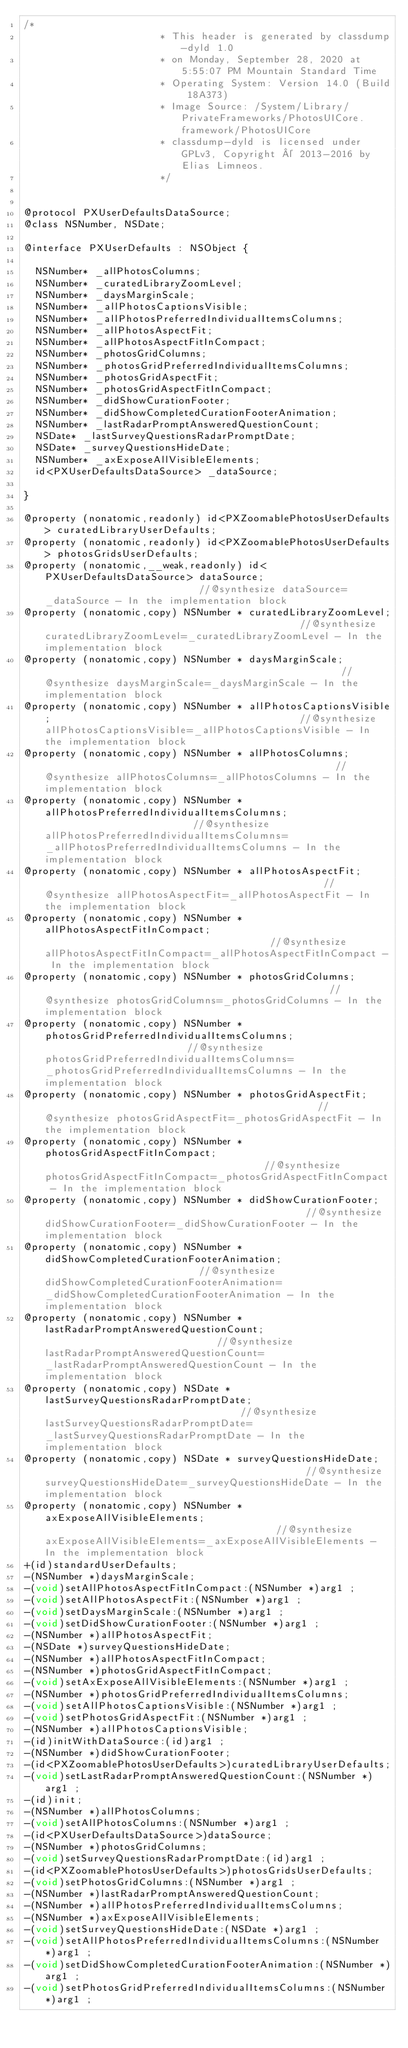<code> <loc_0><loc_0><loc_500><loc_500><_C_>/*
                       * This header is generated by classdump-dyld 1.0
                       * on Monday, September 28, 2020 at 5:55:07 PM Mountain Standard Time
                       * Operating System: Version 14.0 (Build 18A373)
                       * Image Source: /System/Library/PrivateFrameworks/PhotosUICore.framework/PhotosUICore
                       * classdump-dyld is licensed under GPLv3, Copyright © 2013-2016 by Elias Limneos.
                       */


@protocol PXUserDefaultsDataSource;
@class NSNumber, NSDate;

@interface PXUserDefaults : NSObject {

	NSNumber* _allPhotosColumns;
	NSNumber* _curatedLibraryZoomLevel;
	NSNumber* _daysMarginScale;
	NSNumber* _allPhotosCaptionsVisible;
	NSNumber* _allPhotosPreferredIndividualItemsColumns;
	NSNumber* _allPhotosAspectFit;
	NSNumber* _allPhotosAspectFitInCompact;
	NSNumber* _photosGridColumns;
	NSNumber* _photosGridPreferredIndividualItemsColumns;
	NSNumber* _photosGridAspectFit;
	NSNumber* _photosGridAspectFitInCompact;
	NSNumber* _didShowCurationFooter;
	NSNumber* _didShowCompletedCurationFooterAnimation;
	NSNumber* _lastRadarPromptAnsweredQuestionCount;
	NSDate* _lastSurveyQuestionsRadarPromptDate;
	NSDate* _surveyQuestionsHideDate;
	NSNumber* _axExposeAllVisibleElements;
	id<PXUserDefaultsDataSource> _dataSource;

}

@property (nonatomic,readonly) id<PXZoomablePhotosUserDefaults> curatedLibraryUserDefaults; 
@property (nonatomic,readonly) id<PXZoomablePhotosUserDefaults> photosGridsUserDefaults; 
@property (nonatomic,__weak,readonly) id<PXUserDefaultsDataSource> dataSource;                           //@synthesize dataSource=_dataSource - In the implementation block
@property (nonatomic,copy) NSNumber * curatedLibraryZoomLevel;                                           //@synthesize curatedLibraryZoomLevel=_curatedLibraryZoomLevel - In the implementation block
@property (nonatomic,copy) NSNumber * daysMarginScale;                                                   //@synthesize daysMarginScale=_daysMarginScale - In the implementation block
@property (nonatomic,copy) NSNumber * allPhotosCaptionsVisible;                                          //@synthesize allPhotosCaptionsVisible=_allPhotosCaptionsVisible - In the implementation block
@property (nonatomic,copy) NSNumber * allPhotosColumns;                                                  //@synthesize allPhotosColumns=_allPhotosColumns - In the implementation block
@property (nonatomic,copy) NSNumber * allPhotosPreferredIndividualItemsColumns;                          //@synthesize allPhotosPreferredIndividualItemsColumns=_allPhotosPreferredIndividualItemsColumns - In the implementation block
@property (nonatomic,copy) NSNumber * allPhotosAspectFit;                                                //@synthesize allPhotosAspectFit=_allPhotosAspectFit - In the implementation block
@property (nonatomic,copy) NSNumber * allPhotosAspectFitInCompact;                                       //@synthesize allPhotosAspectFitInCompact=_allPhotosAspectFitInCompact - In the implementation block
@property (nonatomic,copy) NSNumber * photosGridColumns;                                                 //@synthesize photosGridColumns=_photosGridColumns - In the implementation block
@property (nonatomic,copy) NSNumber * photosGridPreferredIndividualItemsColumns;                         //@synthesize photosGridPreferredIndividualItemsColumns=_photosGridPreferredIndividualItemsColumns - In the implementation block
@property (nonatomic,copy) NSNumber * photosGridAspectFit;                                               //@synthesize photosGridAspectFit=_photosGridAspectFit - In the implementation block
@property (nonatomic,copy) NSNumber * photosGridAspectFitInCompact;                                      //@synthesize photosGridAspectFitInCompact=_photosGridAspectFitInCompact - In the implementation block
@property (nonatomic,copy) NSNumber * didShowCurationFooter;                                             //@synthesize didShowCurationFooter=_didShowCurationFooter - In the implementation block
@property (nonatomic,copy) NSNumber * didShowCompletedCurationFooterAnimation;                           //@synthesize didShowCompletedCurationFooterAnimation=_didShowCompletedCurationFooterAnimation - In the implementation block
@property (nonatomic,copy) NSNumber * lastRadarPromptAnsweredQuestionCount;                              //@synthesize lastRadarPromptAnsweredQuestionCount=_lastRadarPromptAnsweredQuestionCount - In the implementation block
@property (nonatomic,copy) NSDate * lastSurveyQuestionsRadarPromptDate;                                  //@synthesize lastSurveyQuestionsRadarPromptDate=_lastSurveyQuestionsRadarPromptDate - In the implementation block
@property (nonatomic,copy) NSDate * surveyQuestionsHideDate;                                             //@synthesize surveyQuestionsHideDate=_surveyQuestionsHideDate - In the implementation block
@property (nonatomic,copy) NSNumber * axExposeAllVisibleElements;                                        //@synthesize axExposeAllVisibleElements=_axExposeAllVisibleElements - In the implementation block
+(id)standardUserDefaults;
-(NSNumber *)daysMarginScale;
-(void)setAllPhotosAspectFitInCompact:(NSNumber *)arg1 ;
-(void)setAllPhotosAspectFit:(NSNumber *)arg1 ;
-(void)setDaysMarginScale:(NSNumber *)arg1 ;
-(void)setDidShowCurationFooter:(NSNumber *)arg1 ;
-(NSNumber *)allPhotosAspectFit;
-(NSDate *)surveyQuestionsHideDate;
-(NSNumber *)allPhotosAspectFitInCompact;
-(NSNumber *)photosGridAspectFitInCompact;
-(void)setAxExposeAllVisibleElements:(NSNumber *)arg1 ;
-(NSNumber *)photosGridPreferredIndividualItemsColumns;
-(void)setAllPhotosCaptionsVisible:(NSNumber *)arg1 ;
-(void)setPhotosGridAspectFit:(NSNumber *)arg1 ;
-(NSNumber *)allPhotosCaptionsVisible;
-(id)initWithDataSource:(id)arg1 ;
-(NSNumber *)didShowCurationFooter;
-(id<PXZoomablePhotosUserDefaults>)curatedLibraryUserDefaults;
-(void)setLastRadarPromptAnsweredQuestionCount:(NSNumber *)arg1 ;
-(id)init;
-(NSNumber *)allPhotosColumns;
-(void)setAllPhotosColumns:(NSNumber *)arg1 ;
-(id<PXUserDefaultsDataSource>)dataSource;
-(NSNumber *)photosGridColumns;
-(void)setSurveyQuestionsRadarPromptDate:(id)arg1 ;
-(id<PXZoomablePhotosUserDefaults>)photosGridsUserDefaults;
-(void)setPhotosGridColumns:(NSNumber *)arg1 ;
-(NSNumber *)lastRadarPromptAnsweredQuestionCount;
-(NSNumber *)allPhotosPreferredIndividualItemsColumns;
-(NSNumber *)axExposeAllVisibleElements;
-(void)setSurveyQuestionsHideDate:(NSDate *)arg1 ;
-(void)setAllPhotosPreferredIndividualItemsColumns:(NSNumber *)arg1 ;
-(void)setDidShowCompletedCurationFooterAnimation:(NSNumber *)arg1 ;
-(void)setPhotosGridPreferredIndividualItemsColumns:(NSNumber *)arg1 ;</code> 